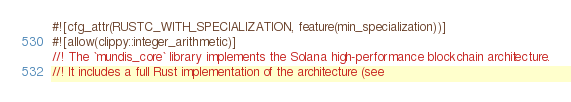Convert code to text. <code><loc_0><loc_0><loc_500><loc_500><_Rust_>#![cfg_attr(RUSTC_WITH_SPECIALIZATION, feature(min_specialization))]
#![allow(clippy::integer_arithmetic)]
//! The `mundis_core` library implements the Solana high-performance blockchain architecture.
//! It includes a full Rust implementation of the architecture (see</code> 